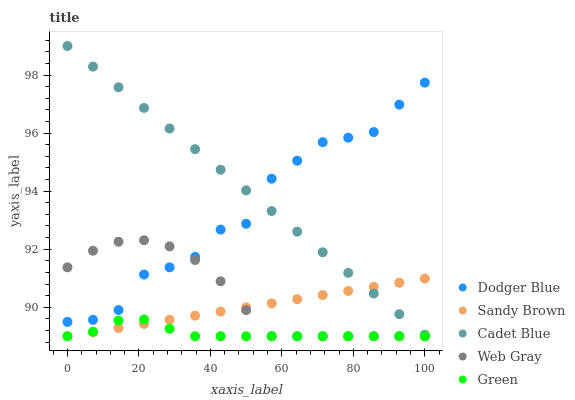Does Green have the minimum area under the curve?
Answer yes or no. Yes. Does Cadet Blue have the maximum area under the curve?
Answer yes or no. Yes. Does Sandy Brown have the minimum area under the curve?
Answer yes or no. No. Does Sandy Brown have the maximum area under the curve?
Answer yes or no. No. Is Sandy Brown the smoothest?
Answer yes or no. Yes. Is Dodger Blue the roughest?
Answer yes or no. Yes. Is Cadet Blue the smoothest?
Answer yes or no. No. Is Cadet Blue the roughest?
Answer yes or no. No. Does Web Gray have the lowest value?
Answer yes or no. Yes. Does Cadet Blue have the lowest value?
Answer yes or no. No. Does Cadet Blue have the highest value?
Answer yes or no. Yes. Does Sandy Brown have the highest value?
Answer yes or no. No. Is Green less than Cadet Blue?
Answer yes or no. Yes. Is Cadet Blue greater than Green?
Answer yes or no. Yes. Does Cadet Blue intersect Dodger Blue?
Answer yes or no. Yes. Is Cadet Blue less than Dodger Blue?
Answer yes or no. No. Is Cadet Blue greater than Dodger Blue?
Answer yes or no. No. Does Green intersect Cadet Blue?
Answer yes or no. No. 